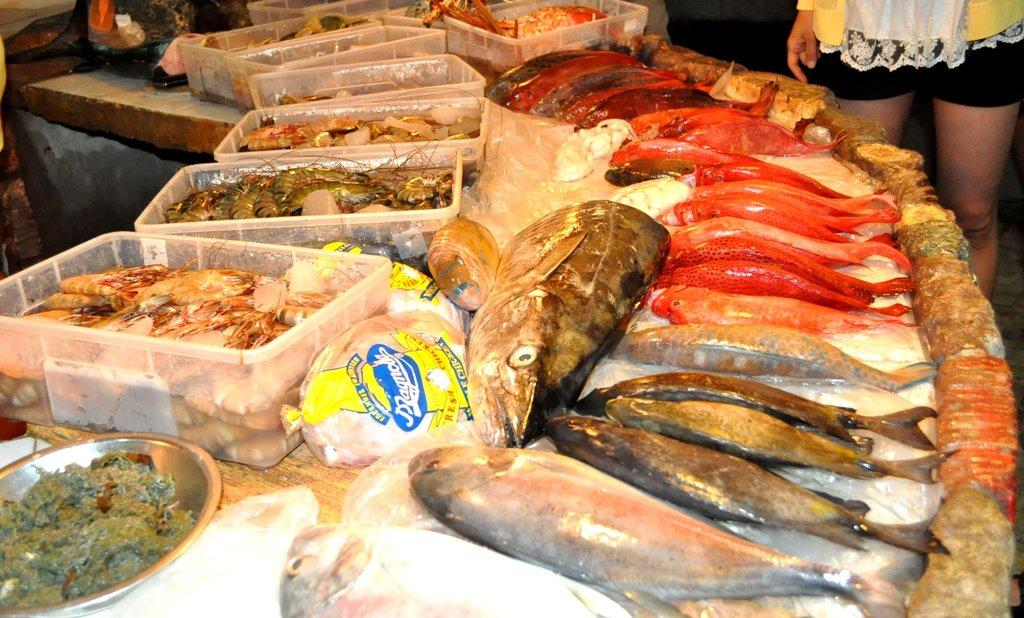What type of animals can be seen in the foreground of the image? There are marine animals like fish and prawns in the foreground of the image. What objects are present in the foreground of the image? There are covers, boxes, and a plate in the foreground of the image. Can you describe the person in the image? There is a person on the right side of the image. What type of nation is depicted in the image? There is no nation depicted in the image; it features marine animals, objects, and a person. Is there a prison visible in the image? There is no prison present in the image. 